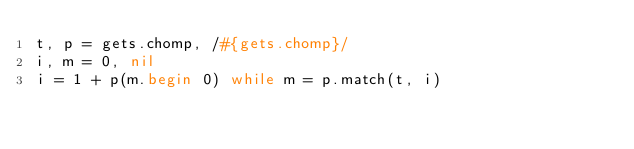Convert code to text. <code><loc_0><loc_0><loc_500><loc_500><_Ruby_>t, p = gets.chomp, /#{gets.chomp}/
i, m = 0, nil
i = 1 + p(m.begin 0) while m = p.match(t, i)</code> 